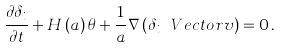<formula> <loc_0><loc_0><loc_500><loc_500>\frac { \partial \delta _ { i } } { \partial t } + H \left ( a \right ) \theta + \frac { 1 } { a } \nabla \left ( \delta _ { i } \ V e c t o r { v } \right ) = 0 \, .</formula> 